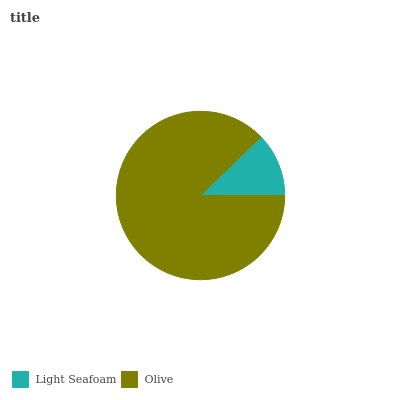Is Light Seafoam the minimum?
Answer yes or no. Yes. Is Olive the maximum?
Answer yes or no. Yes. Is Olive the minimum?
Answer yes or no. No. Is Olive greater than Light Seafoam?
Answer yes or no. Yes. Is Light Seafoam less than Olive?
Answer yes or no. Yes. Is Light Seafoam greater than Olive?
Answer yes or no. No. Is Olive less than Light Seafoam?
Answer yes or no. No. Is Olive the high median?
Answer yes or no. Yes. Is Light Seafoam the low median?
Answer yes or no. Yes. Is Light Seafoam the high median?
Answer yes or no. No. Is Olive the low median?
Answer yes or no. No. 